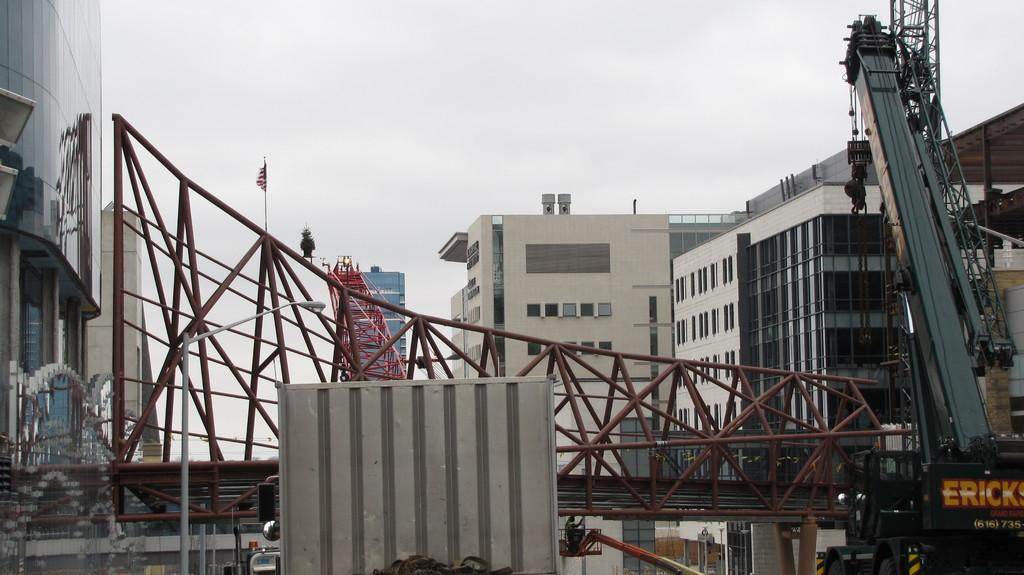What type of structures can be seen in the image? There are buildings in the image. What construction equipment is present in the image? There are cranes in the image. What material is used for the objects in the image? There are metal objects in the image. What is visible in the background of the image? The sky is visible in the image. What symbol can be seen in the image? There is a flag in the image. What type of information is displayed in the image? There is a board with text in the image. Can you see a bomb exploding in the image? No, there is no bomb or explosion present in the image. What type of neck accessory is worn by the crane in the image? There are no neck accessories or cranes wearing accessories in the image. 